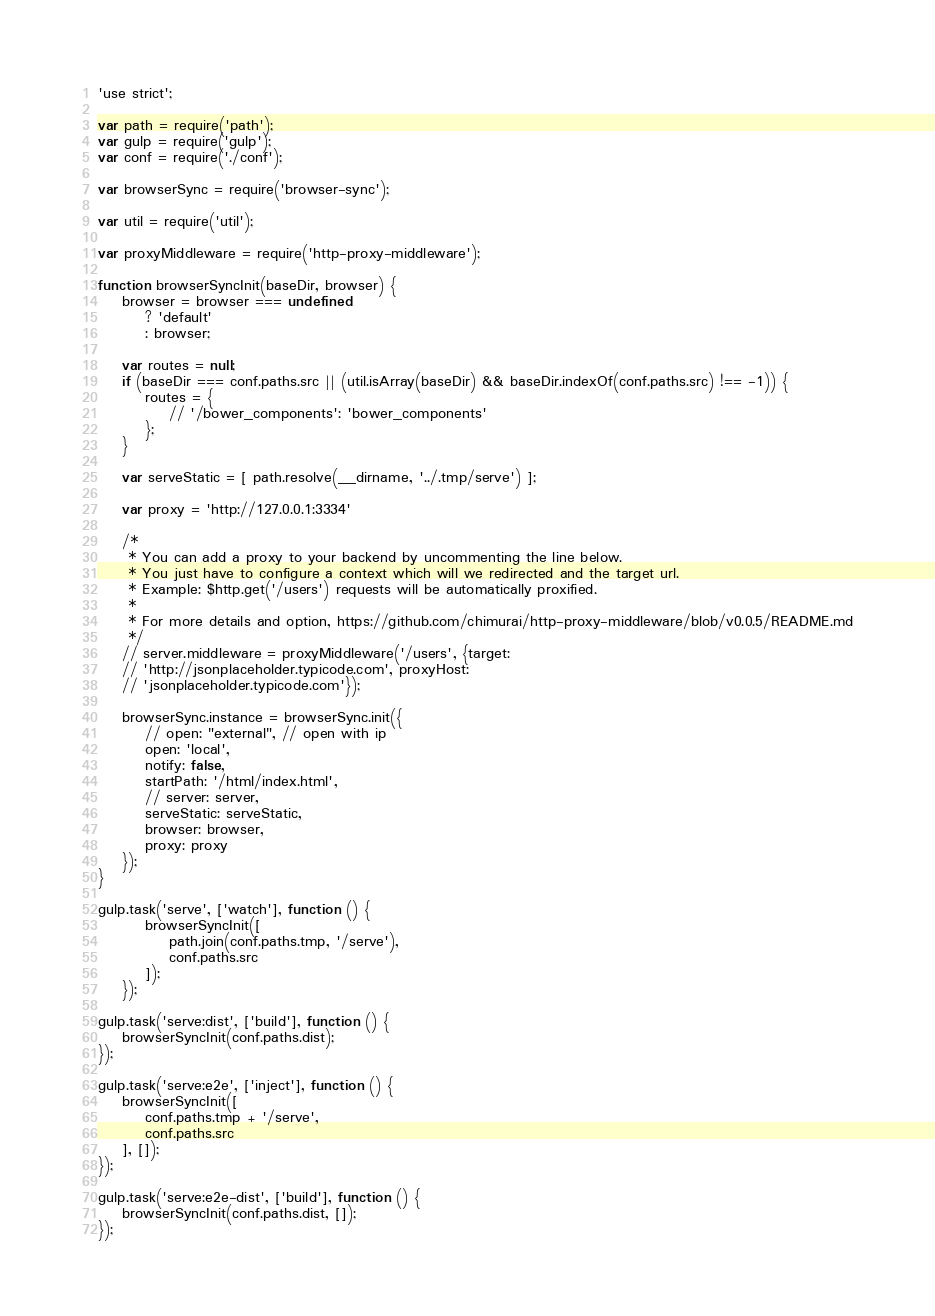Convert code to text. <code><loc_0><loc_0><loc_500><loc_500><_JavaScript_>'use strict';

var path = require('path');
var gulp = require('gulp');
var conf = require('./conf');

var browserSync = require('browser-sync');

var util = require('util');

var proxyMiddleware = require('http-proxy-middleware');

function browserSyncInit(baseDir, browser) {
    browser = browser === undefined
        ? 'default'
        : browser;

    var routes = null;
    if (baseDir === conf.paths.src || (util.isArray(baseDir) && baseDir.indexOf(conf.paths.src) !== -1)) {
        routes = {
            // '/bower_components': 'bower_components'
        };
    }

    var serveStatic = [ path.resolve(__dirname, '../.tmp/serve') ];

    var proxy = 'http://127.0.0.1:3334'

    /*
     * You can add a proxy to your backend by uncommenting the line below.
     * You just have to configure a context which will we redirected and the target url.
     * Example: $http.get('/users') requests will be automatically proxified.
     *
     * For more details and option, https://github.com/chimurai/http-proxy-middleware/blob/v0.0.5/README.md
     */
    // server.middleware = proxyMiddleware('/users', {target:
    // 'http://jsonplaceholder.typicode.com', proxyHost:
    // 'jsonplaceholder.typicode.com'});

    browserSync.instance = browserSync.init({
        // open: "external", // open with ip
        open: 'local',
        notify: false,
        startPath: '/html/index.html',
        // server: server,
        serveStatic: serveStatic,
        browser: browser,
        proxy: proxy
    });
}

gulp.task('serve', ['watch'], function () {
        browserSyncInit([
            path.join(conf.paths.tmp, '/serve'),
            conf.paths.src
        ]);
    });

gulp.task('serve:dist', ['build'], function () {
    browserSyncInit(conf.paths.dist);
});

gulp.task('serve:e2e', ['inject'], function () {
    browserSyncInit([
        conf.paths.tmp + '/serve',
        conf.paths.src
    ], []);
});

gulp.task('serve:e2e-dist', ['build'], function () {
    browserSyncInit(conf.paths.dist, []);
});
</code> 